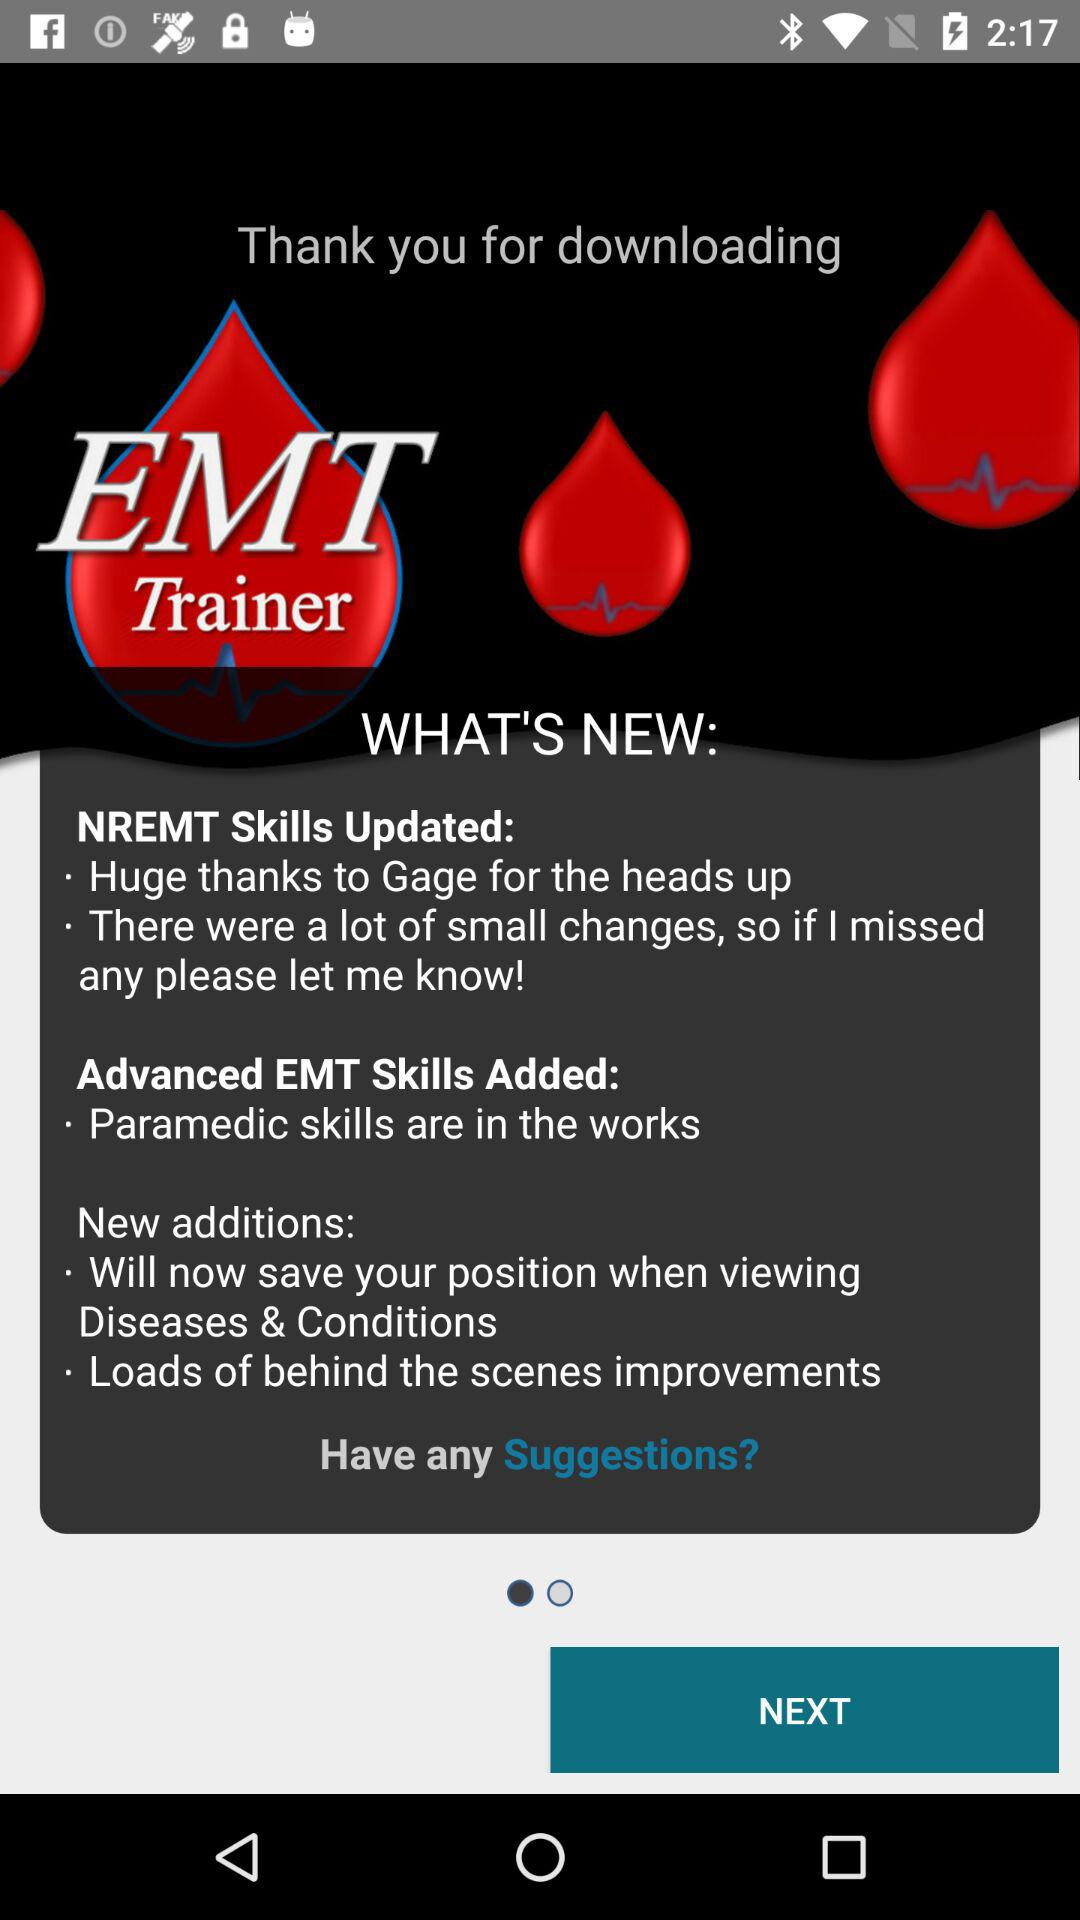What is the application name?
Answer the question using a single word or phrase. The application name is "EMT Trainer" 